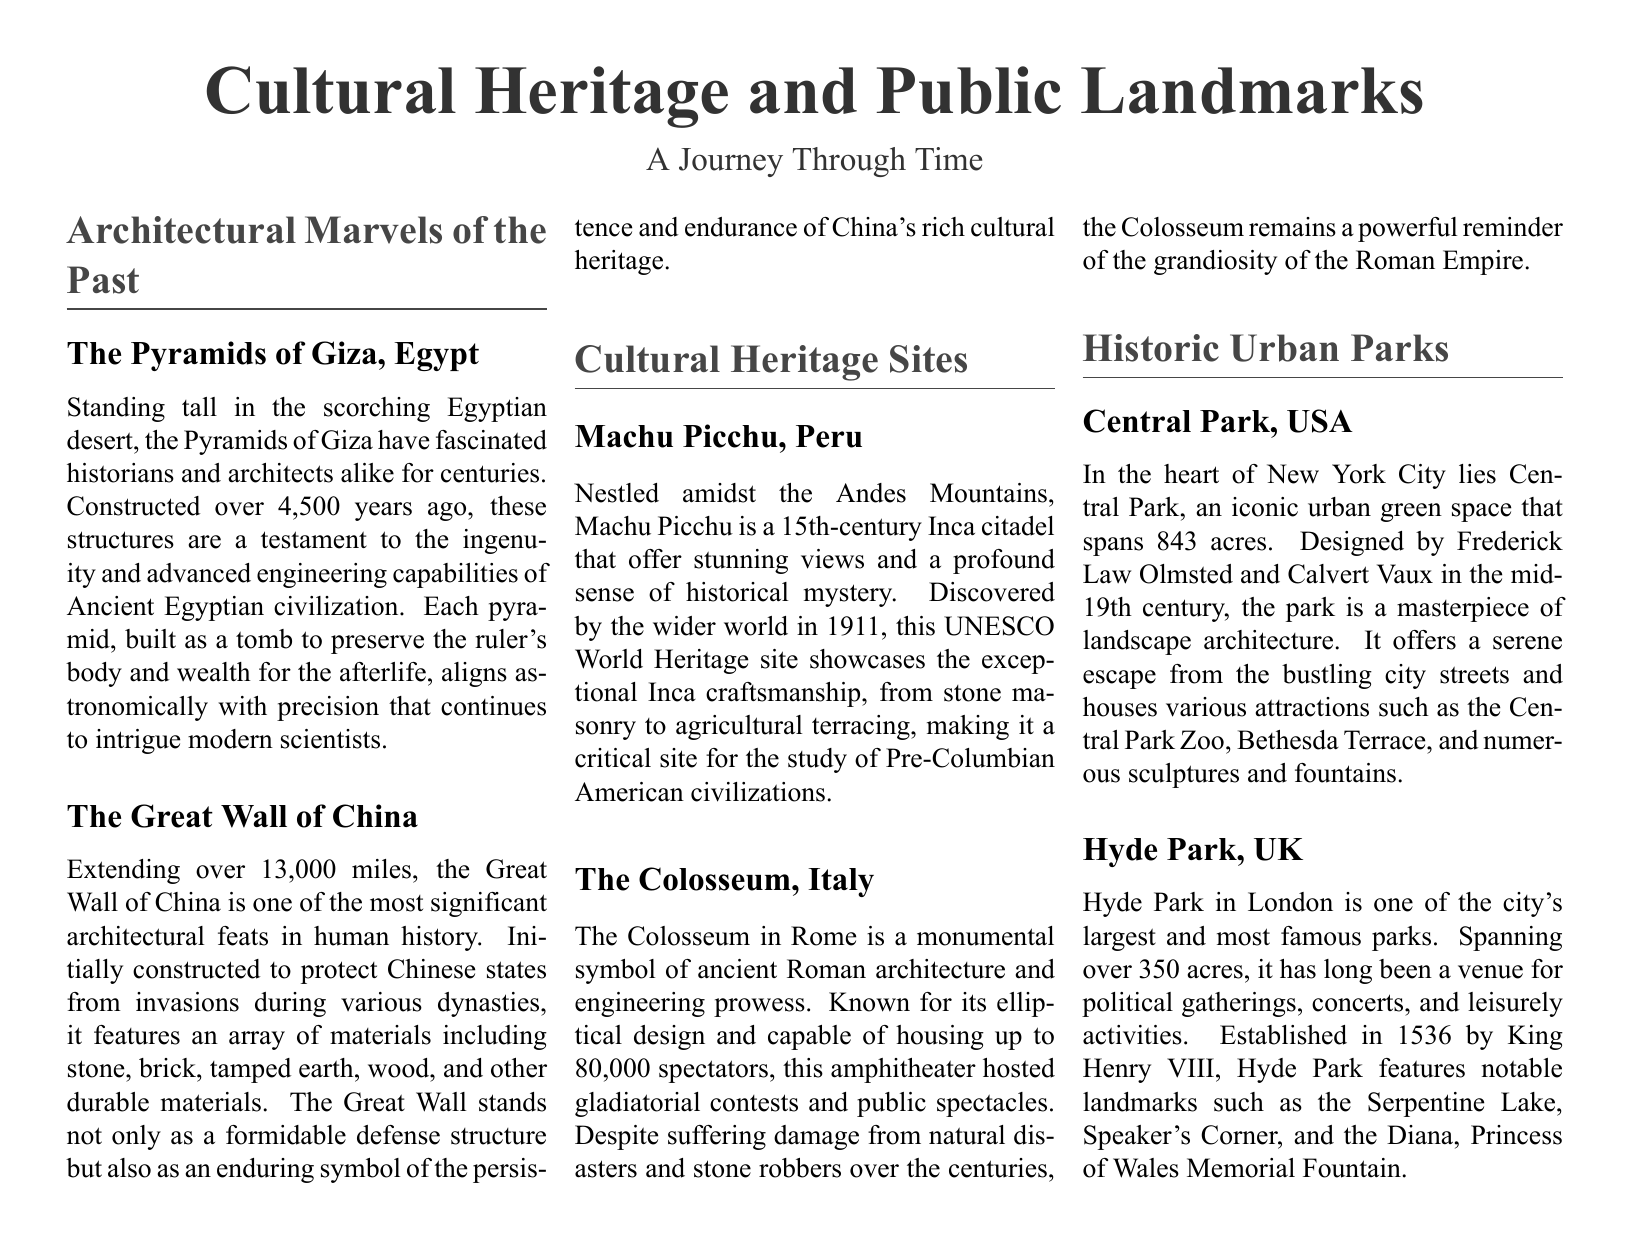What is the height of the Pyramids of Giza? The document does not specify the exact height, only that they stand tall in the Egyptian desert.
Answer: Not specified How many miles does the Great Wall of China extend? The document states that the Great Wall of China extends over 13,000 miles.
Answer: 13,000 miles What century was Machu Picchu constructed? The document mentions that Machu Picchu is a 15th-century Inca citadel.
Answer: 15th century How many spectators could the Colosseum house? According to the document, the Colosseum could house up to 80,000 spectators.
Answer: 80,000 Who designed Central Park? The document states that Central Park was designed by Frederick Law Olmsted and Calvert Vaux.
Answer: Frederick Law Olmsted and Calvert Vaux What is the area of Central Park in acres? The document specifies that Central Park spans 843 acres.
Answer: 843 acres Which country is home to historic Hyde Park? The document indicates that Hyde Park is located in the United Kingdom (UK).
Answer: UK What significant feature does Hyde Park have? The document mentions notable landmarks, including the Diana, Princess of Wales Memorial Fountain.
Answer: Diana, Princess of Wales Memorial Fountain What type of structure is the Colosseum? The document describes the Colosseum as an amphitheater.
Answer: Amphitheater 